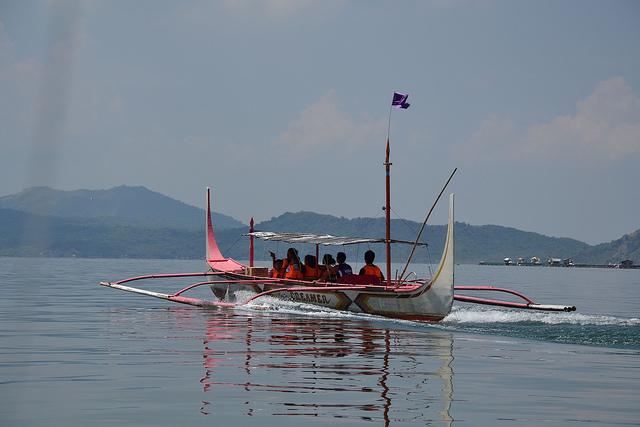Is the water frozen over?
Concise answer only. No. Do you think this is in America?
Be succinct. No. Does that boat have a flag?
Answer briefly. Yes. What is the boat pulling?
Be succinct. Nothing. 